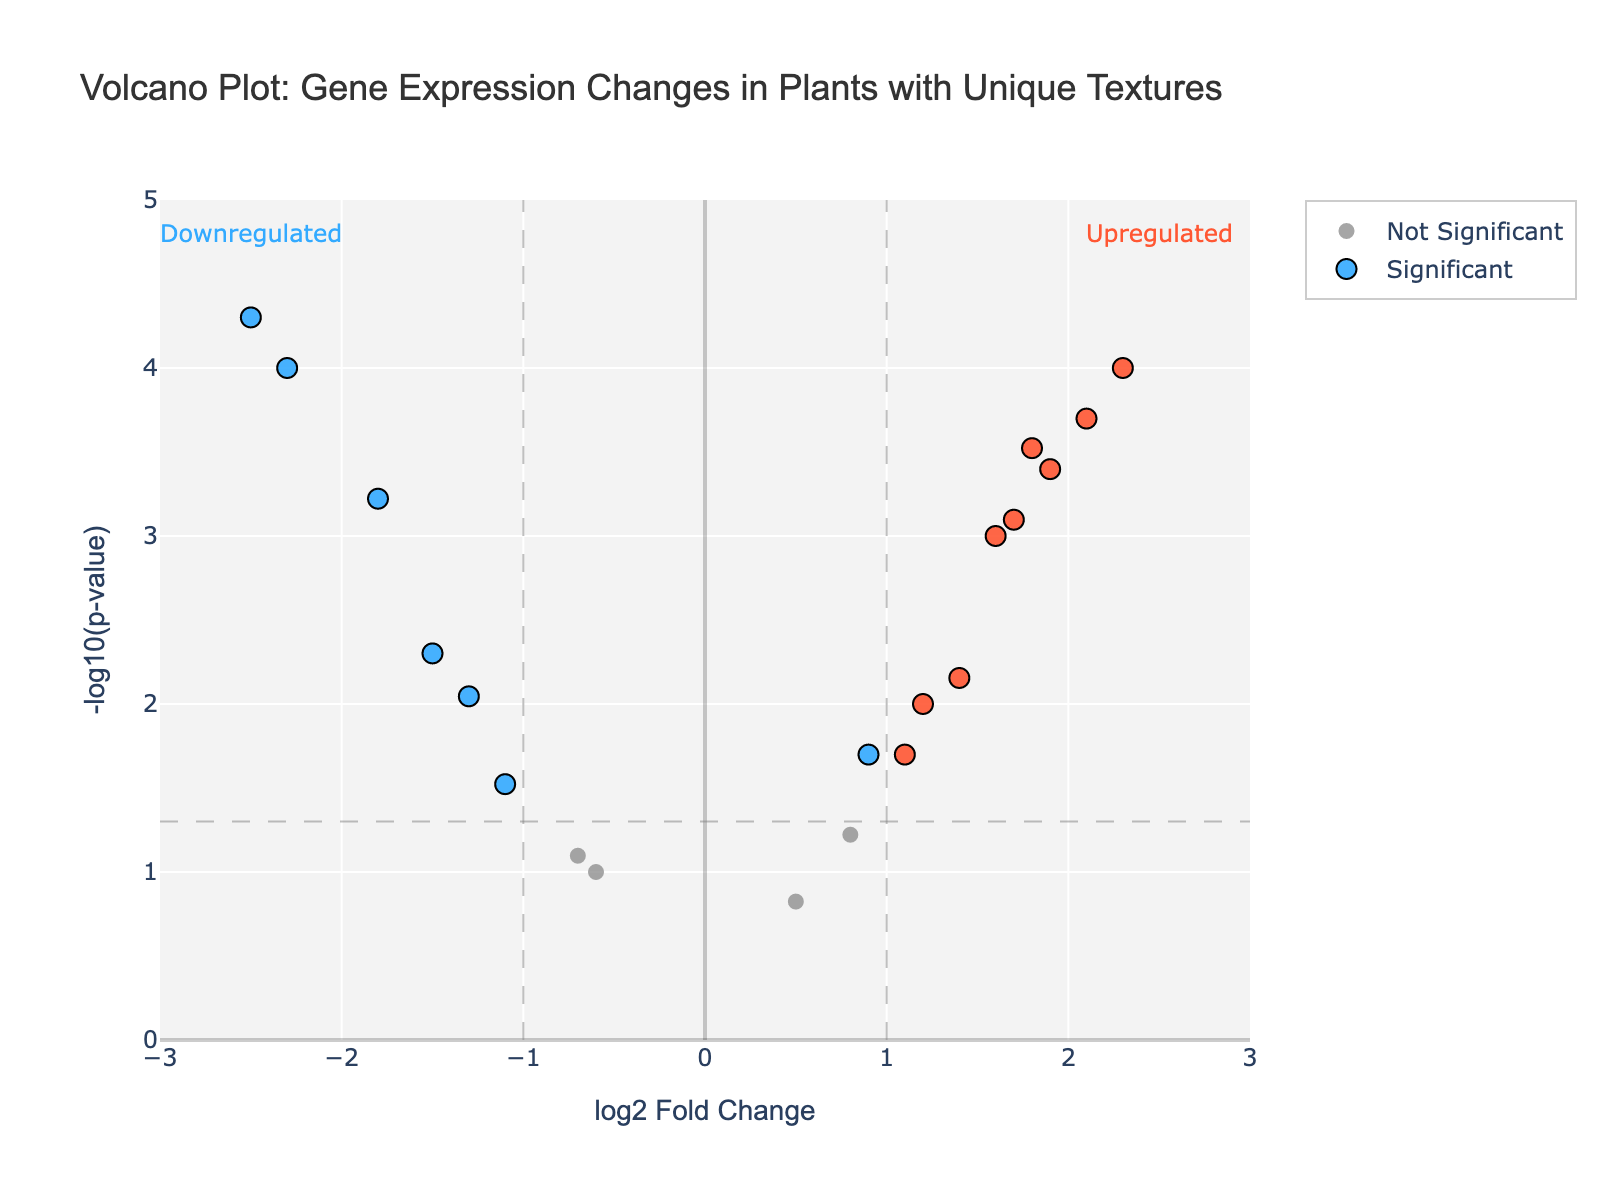What's the title of the figure? The title is typically located at the top of the figure. In this case, it's labeled explicitly.
Answer: Volcano Plot: Gene Expression Changes in Plants with Unique Textures What is represented on the x-axis? The x-axis usually represents 'log2 Fold Change' in a Volcano Plot, as stated in the code.
Answer: log2 Fold Change What is represented on the y-axis? The y-axis typically illustrates '-log10(p-value)' in a Volcano Plot, as seen in the code and description.
Answer: -log10(p-value) Which gene is upregulated the most significantly? Upregulated genes are those with positive log2FoldChange. The one with the highest log2FoldChange value and the lowest p-value will be the most significant. This is indicated in the figure as the highest point on the right side.
Answer: Lipid transfer protein Which gene is downregulated the most significantly? Downregulated genes have negative log2FoldChange. The one with the lowest log2FoldChange value and the lowest p-value will be the most significant. This is indicated in the figure as the highest point on the left side.
Answer: Expansin How many genes are significantly upregulated? Significant upregulation is determined by having a positive log2FoldChange and a p-value less than 0.05. Count the number of points on the right side above the significance threshold.
Answer: 9 Compare the regulation of 'Aquaporin' and 'Casparian strip membrane protein': which one is more significant? To determine significance, compare both the -log10(p-value) and impact (log2FoldChange). The one with higher -log10(p-value) and greater absolute fold change is more significant. 'Aquaporin' has a higher -log10(p-value) than 'Casparian strip membrane protein'.
Answer: Aquaporin What is the overall trend of 'Cutin synthase' in terms of regulation? Look at the log2FoldChange for 'Cutin synthase'. A negative value indicates downregulation, and the specific value helps judge the severity.
Answer: Downregulated List two genes with similar (-log10(p-value)) but opposite regulation direction. Identifying two genes with similar vertical positions (similar p-values) but opposite signs on their log2FoldChange (one positive, one negative). For example, 'Aquaporin' and 'Casparian strip membrane protein'.
Answer: Aquaporin and Casparian strip membrane protein Which gene has the least significant change? Identify the gene closest to the bottom of the y-axis since it will have the smallest -log10(p-value).
Answer: Beta-glucan synthase 